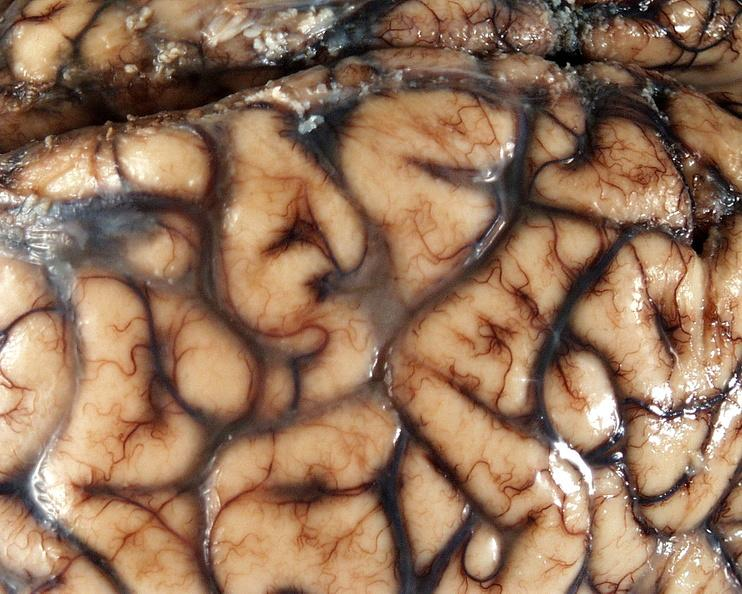s abdomen present?
Answer the question using a single word or phrase. No 